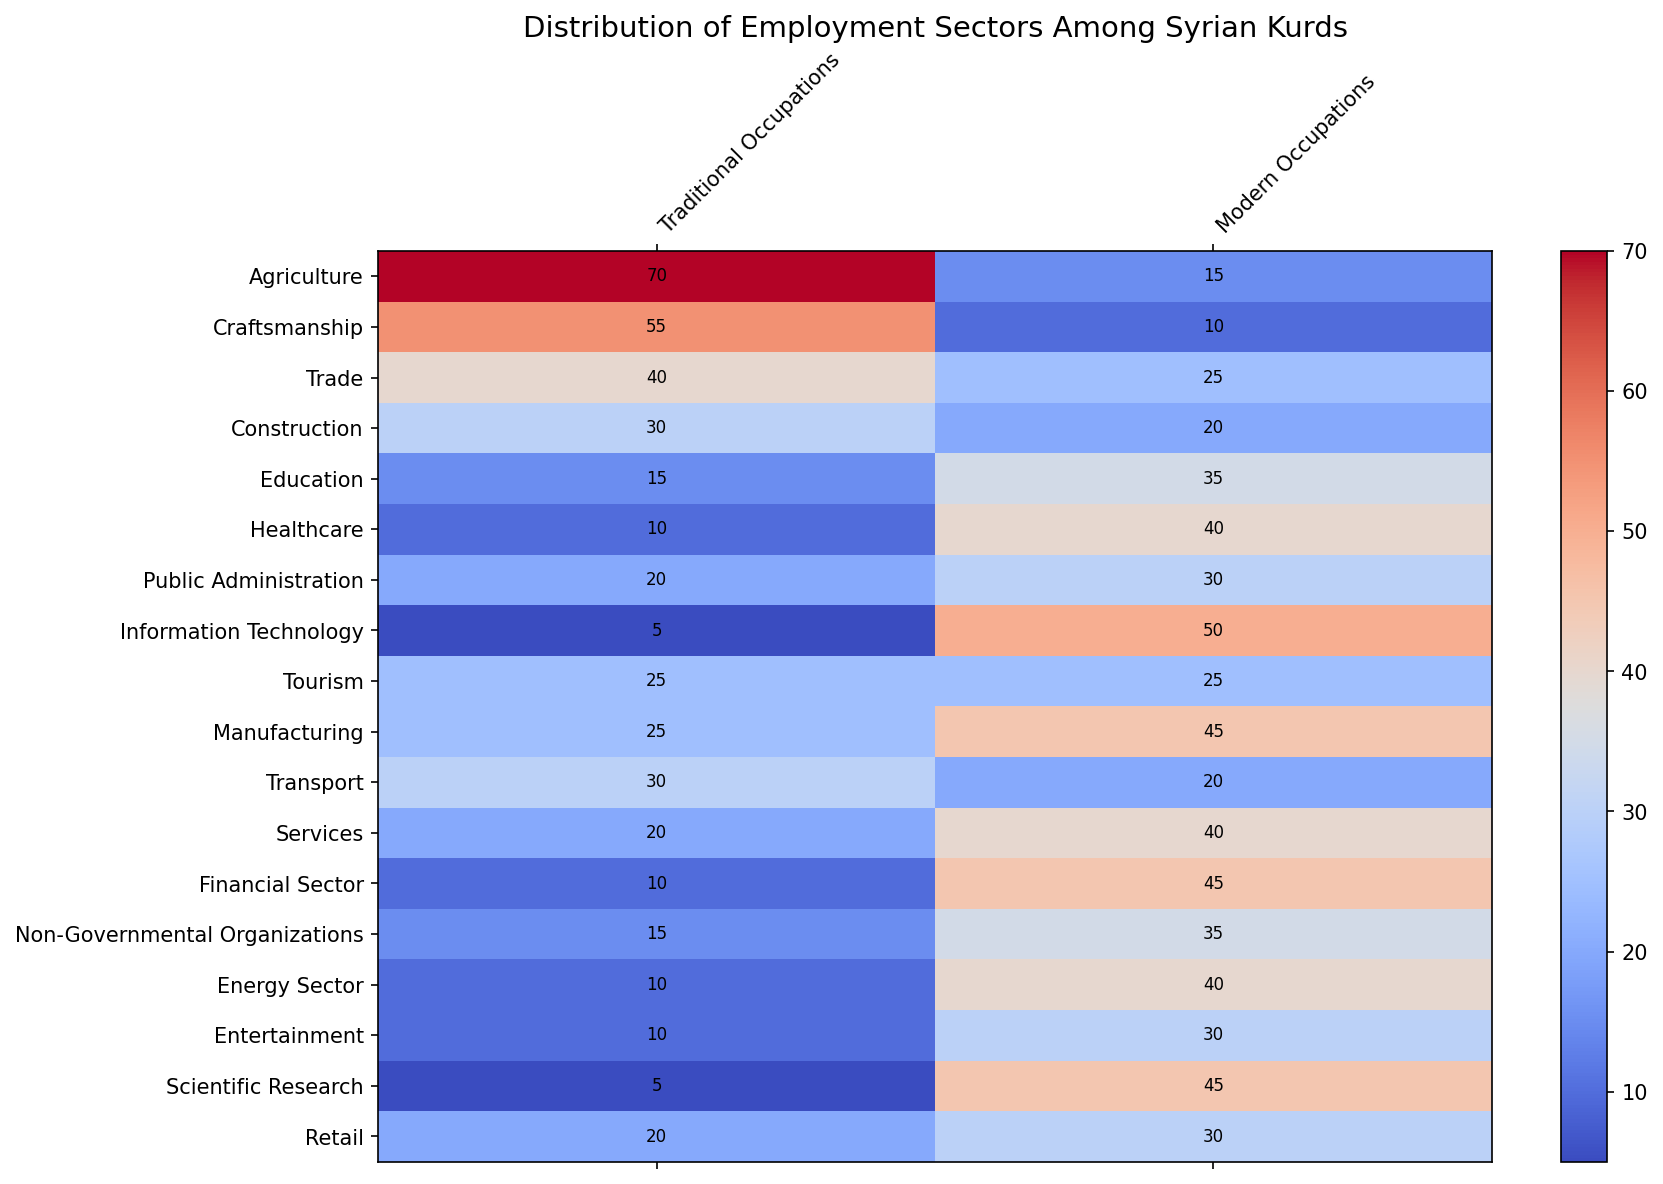Which employment sector has the highest percentage in Traditional Occupations? Look for the cell with the highest value in the Traditional Occupations column. Agriculture has the highest value, which is 70.
Answer: Agriculture Which two sectors combined have the most employees in Traditional Occupations? Find the top two values in the Traditional Occupations column and sum them. The top two values are Agriculture (70) and Craftsmanship (55). The total is 70 + 55 = 125.
Answer: Agriculture and Craftsmanship Which sector has a balanced distribution between Traditional and Modern Occupations? Look for the row where the values for Traditional and Modern Occupations are closest. Tourism has equal values of 25 for both types of occupations.
Answer: Tourism How many more people are employed in Modern Occupations in Information Technology compared to Traditional Occupations in the same sector? Subtract the Traditional Occupations value from the Modern Occupations value for Information Technology. 50 - 5 = 45.
Answer: 45 Which sector has the lowest percentage in Traditional Occupations, and what is that percentage? Look for the smallest value in the Traditional Occupations column. Information Technology and Scientific Research both have the lowest value, which is 5.
Answer: Information Technology and Scientific Research, 5 What is the average percentage of people in Modern Occupations across all sectors? Sum all values in the Modern Occupations column and divide by the number of sectors. (15 + 10 + 25 + 20 + 35 + 40 + 30 + 50 + 25 + 45 + 20 + 40 + 45 + 35 + 40 + 30 + 45 + 30) = 570. The total number of sectors is 18, so the average is 570 / 18 = 31.67.
Answer: 31.67 Which sector has more people in Modern Occupations but less in Traditional Occupations compared to Services? Compare the cells. Both Healthcare and Manufacturing have this property: 40 (Modern in Healthcare) > 40 (Modern in Services) and 10 (Traditional in Healthcare) < 20 (Traditional in Services). Also, 45 (Modern in Manufacturing) > 40 (Modern in Services) and 25 (Traditional in Manufacturing) < 20 (Traditional in Services).
Answer: Healthcare and Manufacturing How does the Manufacturing sector compare to the Energy Sector in both Traditional and Modern Occupations? Compare the values for both sectors: Manufacturing (Traditional: 25, Modern: 45), Energy (Traditional: 10, Modern: 40). Manufacturing has more in both Traditional (25 vs 10) and Modern (45 vs 40).
Answer: Manufacturing has more in both Traditional and Modern Occupations What is the combined percentage of people in Scientific Research for both Traditional and Modern Occupations? Sum the values for Traditional and Modern Occupations in Scientific Research. 5 (Traditional) + 45 (Modern) = 50.
Answer: 50 